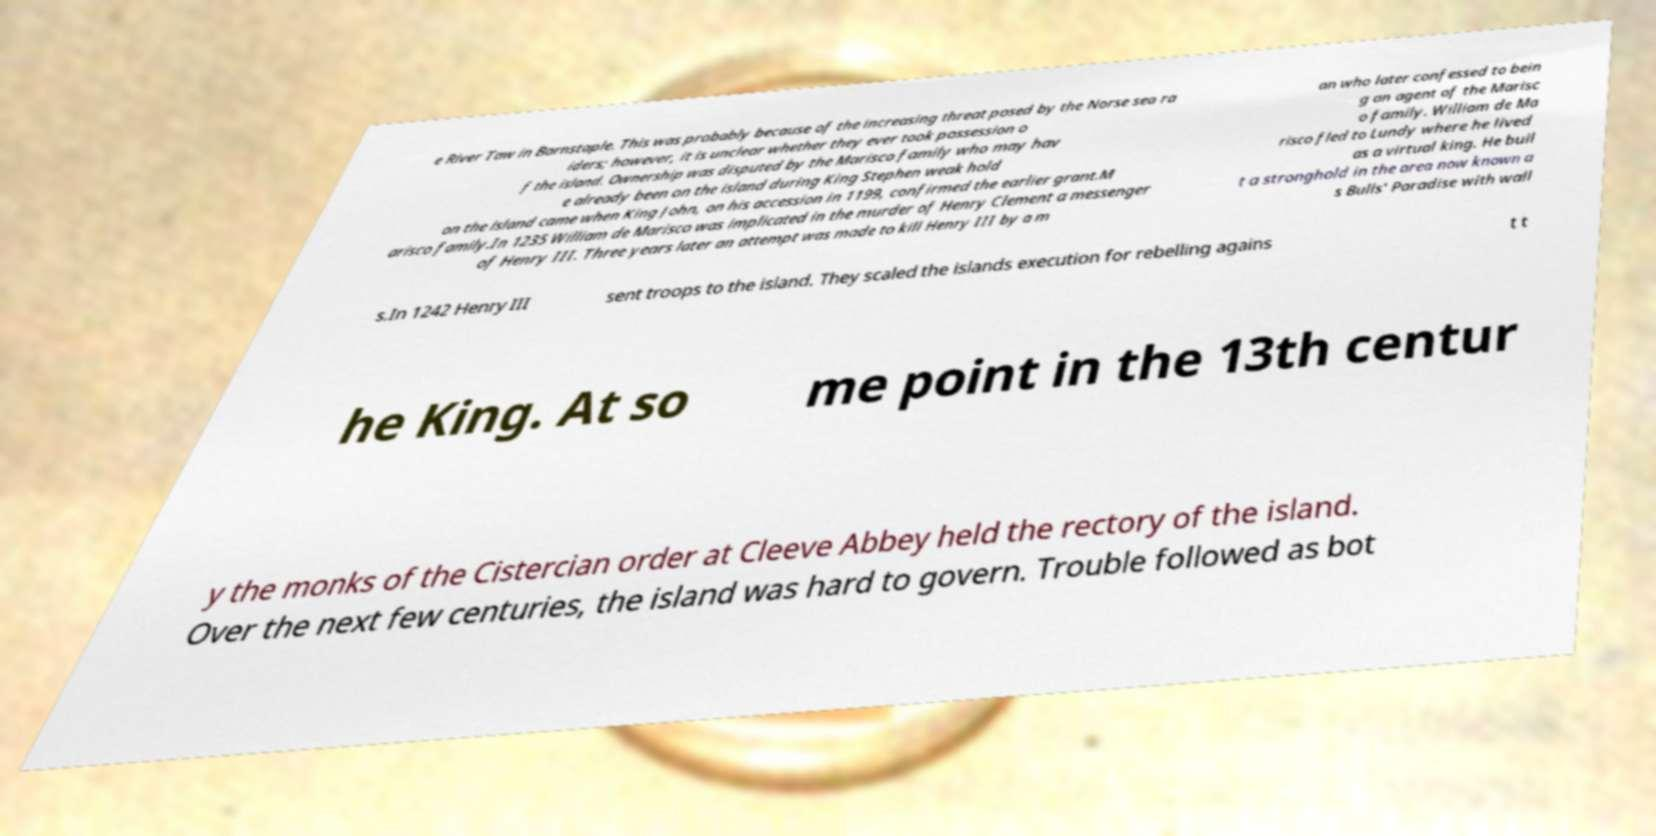There's text embedded in this image that I need extracted. Can you transcribe it verbatim? e River Taw in Barnstaple. This was probably because of the increasing threat posed by the Norse sea ra iders; however, it is unclear whether they ever took possession o f the island. Ownership was disputed by the Marisco family who may hav e already been on the island during King Stephen weak hold on the island came when King John, on his accession in 1199, confirmed the earlier grant.M arisco family.In 1235 William de Marisco was implicated in the murder of Henry Clement a messenger of Henry III. Three years later an attempt was made to kill Henry III by a m an who later confessed to bein g an agent of the Marisc o family. William de Ma risco fled to Lundy where he lived as a virtual king. He buil t a stronghold in the area now known a s Bulls' Paradise with wall s.In 1242 Henry III sent troops to the island. They scaled the islands execution for rebelling agains t t he King. At so me point in the 13th centur y the monks of the Cistercian order at Cleeve Abbey held the rectory of the island. Over the next few centuries, the island was hard to govern. Trouble followed as bot 